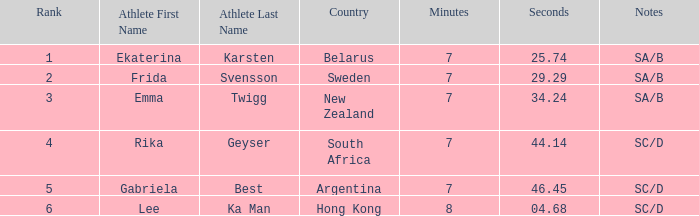What is the duration of frida svensson's race with sa/b mentioned in the notes? 7:29.29. 